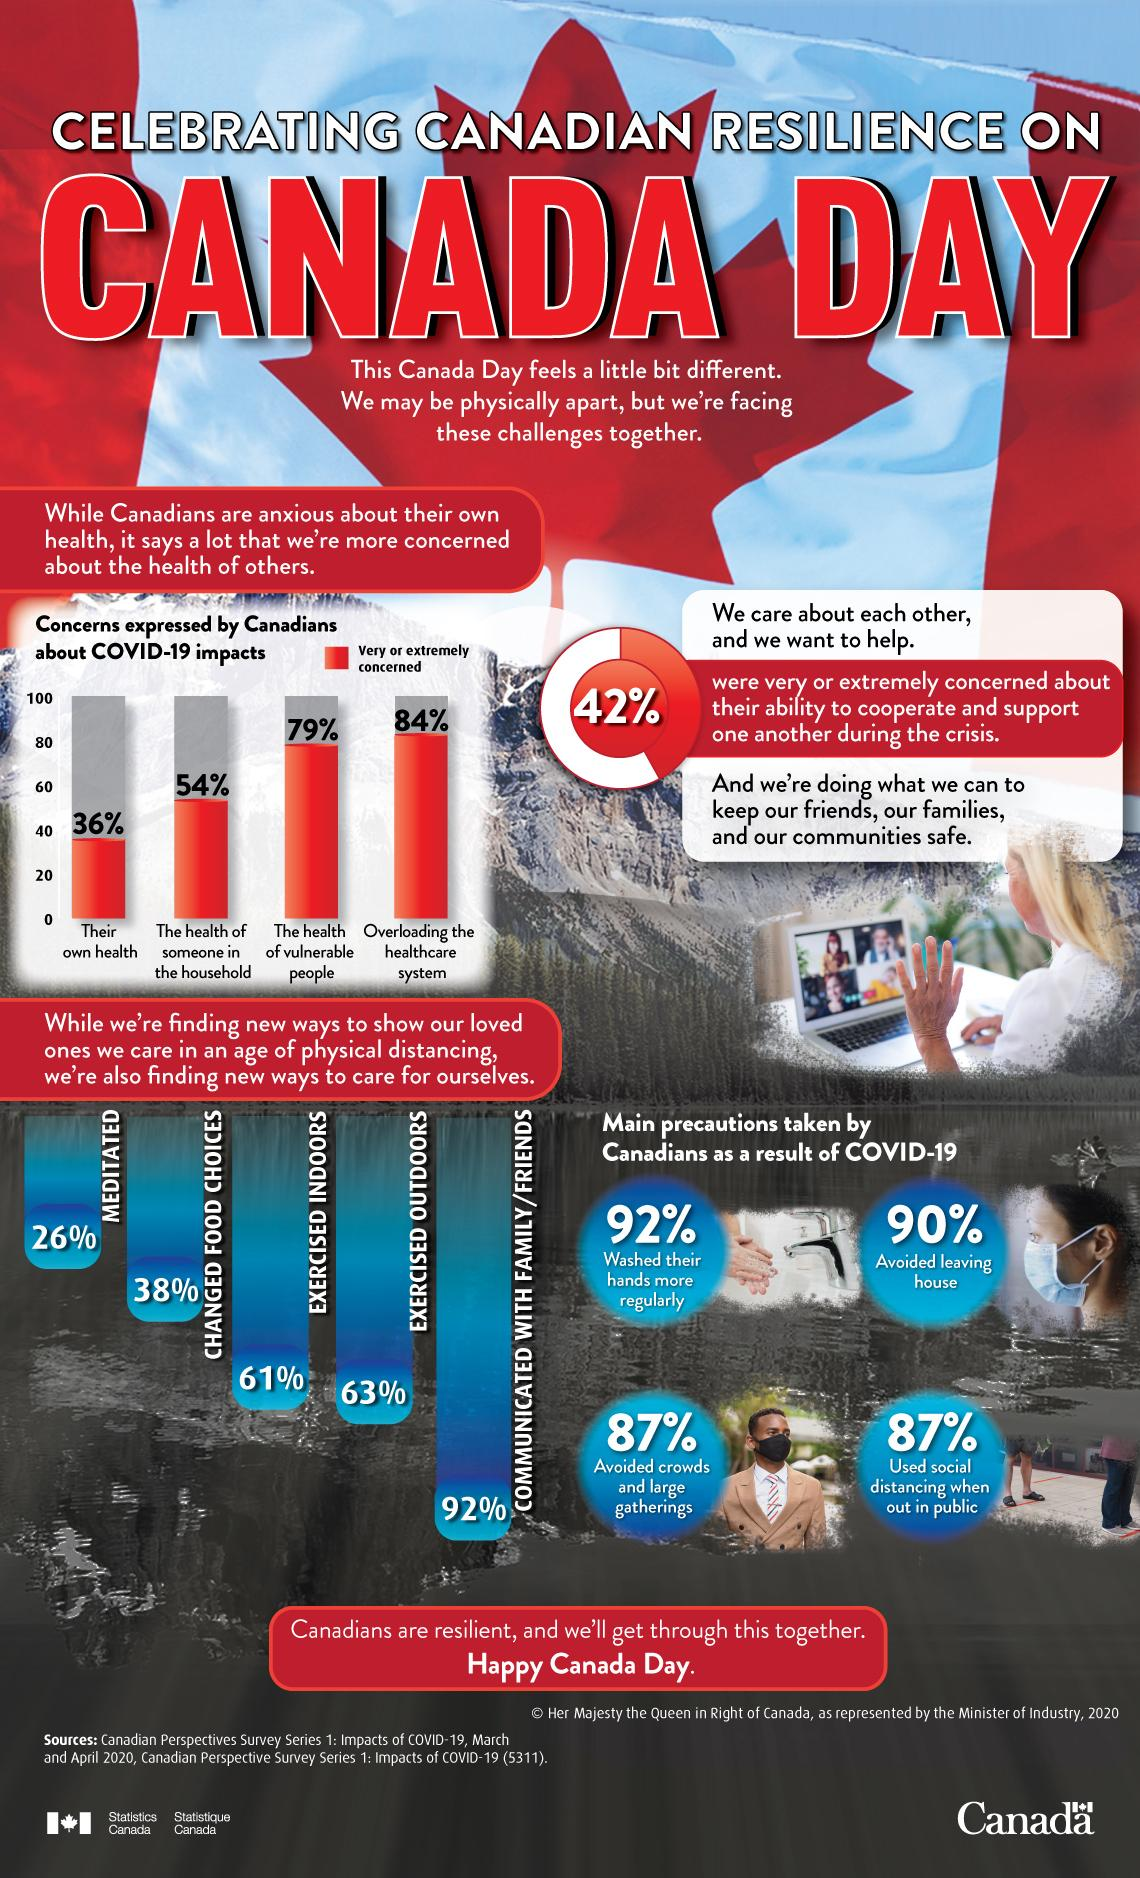Outline some significant characteristics in this image. The biggest concern of Canadians regarding the impacts of COVID-19 is the potential overloading of the healthcare system. 